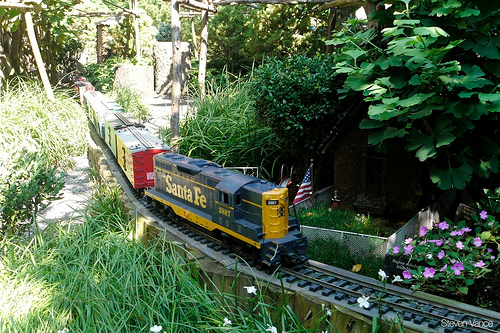Please provide the bounding box coordinate of the region this sentence describes: text on the side of a train. The bounding box coordinate for the region containing the text on the side of the train is [0.31, 0.51, 0.43, 0.58]. 